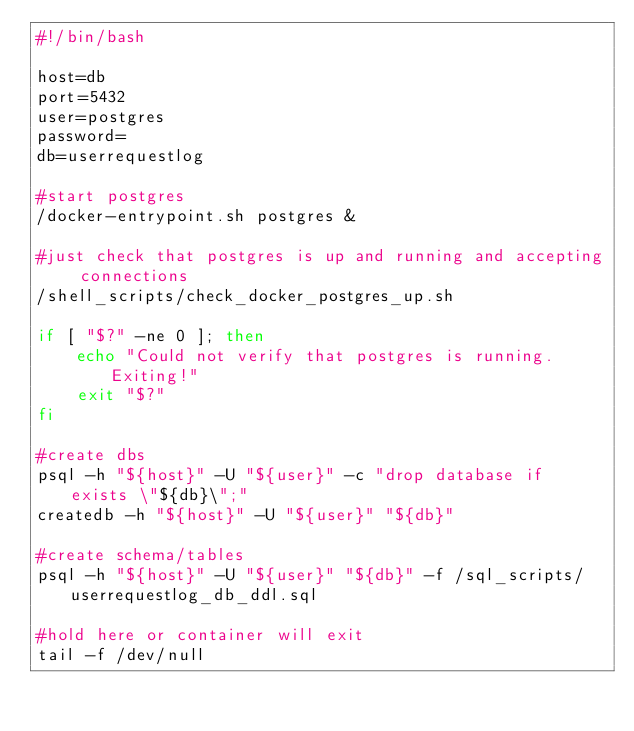<code> <loc_0><loc_0><loc_500><loc_500><_Bash_>#!/bin/bash

host=db
port=5432
user=postgres
password=
db=userrequestlog

#start postgres
/docker-entrypoint.sh postgres &

#just check that postgres is up and running and accepting connections
/shell_scripts/check_docker_postgres_up.sh

if [ "$?" -ne 0 ]; then
    echo "Could not verify that postgres is running. Exiting!"
    exit "$?"
fi

#create dbs
psql -h "${host}" -U "${user}" -c "drop database if exists \"${db}\";"
createdb -h "${host}" -U "${user}" "${db}"

#create schema/tables
psql -h "${host}" -U "${user}" "${db}" -f /sql_scripts/userrequestlog_db_ddl.sql

#hold here or container will exit
tail -f /dev/null
</code> 